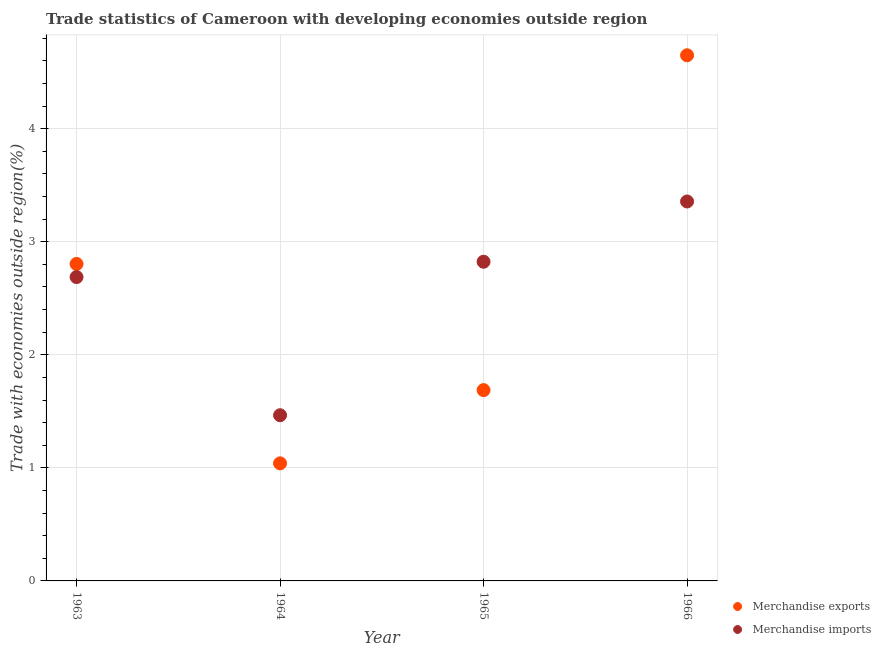What is the merchandise imports in 1963?
Make the answer very short. 2.69. Across all years, what is the maximum merchandise exports?
Offer a very short reply. 4.65. Across all years, what is the minimum merchandise exports?
Keep it short and to the point. 1.04. In which year was the merchandise imports maximum?
Provide a short and direct response. 1966. In which year was the merchandise imports minimum?
Ensure brevity in your answer.  1964. What is the total merchandise exports in the graph?
Give a very brief answer. 10.18. What is the difference between the merchandise exports in 1965 and that in 1966?
Ensure brevity in your answer.  -2.96. What is the difference between the merchandise imports in 1963 and the merchandise exports in 1966?
Provide a succinct answer. -1.96. What is the average merchandise exports per year?
Ensure brevity in your answer.  2.55. In the year 1966, what is the difference between the merchandise exports and merchandise imports?
Provide a succinct answer. 1.29. What is the ratio of the merchandise imports in 1964 to that in 1965?
Your answer should be very brief. 0.52. What is the difference between the highest and the second highest merchandise imports?
Keep it short and to the point. 0.53. What is the difference between the highest and the lowest merchandise imports?
Offer a terse response. 1.89. Is the sum of the merchandise exports in 1963 and 1965 greater than the maximum merchandise imports across all years?
Give a very brief answer. Yes. Is the merchandise exports strictly greater than the merchandise imports over the years?
Offer a terse response. No. How many dotlines are there?
Your answer should be compact. 2. How many years are there in the graph?
Offer a terse response. 4. Are the values on the major ticks of Y-axis written in scientific E-notation?
Keep it short and to the point. No. Does the graph contain any zero values?
Offer a very short reply. No. Does the graph contain grids?
Ensure brevity in your answer.  Yes. Where does the legend appear in the graph?
Offer a very short reply. Bottom right. What is the title of the graph?
Offer a very short reply. Trade statistics of Cameroon with developing economies outside region. Does "Investment" appear as one of the legend labels in the graph?
Keep it short and to the point. No. What is the label or title of the X-axis?
Your answer should be compact. Year. What is the label or title of the Y-axis?
Provide a short and direct response. Trade with economies outside region(%). What is the Trade with economies outside region(%) of Merchandise exports in 1963?
Offer a terse response. 2.8. What is the Trade with economies outside region(%) in Merchandise imports in 1963?
Provide a short and direct response. 2.69. What is the Trade with economies outside region(%) of Merchandise exports in 1964?
Keep it short and to the point. 1.04. What is the Trade with economies outside region(%) of Merchandise imports in 1964?
Offer a very short reply. 1.47. What is the Trade with economies outside region(%) of Merchandise exports in 1965?
Offer a very short reply. 1.69. What is the Trade with economies outside region(%) of Merchandise imports in 1965?
Ensure brevity in your answer.  2.82. What is the Trade with economies outside region(%) in Merchandise exports in 1966?
Offer a very short reply. 4.65. What is the Trade with economies outside region(%) in Merchandise imports in 1966?
Provide a succinct answer. 3.36. Across all years, what is the maximum Trade with economies outside region(%) in Merchandise exports?
Your answer should be very brief. 4.65. Across all years, what is the maximum Trade with economies outside region(%) in Merchandise imports?
Ensure brevity in your answer.  3.36. Across all years, what is the minimum Trade with economies outside region(%) of Merchandise exports?
Offer a terse response. 1.04. Across all years, what is the minimum Trade with economies outside region(%) of Merchandise imports?
Your answer should be very brief. 1.47. What is the total Trade with economies outside region(%) in Merchandise exports in the graph?
Provide a succinct answer. 10.18. What is the total Trade with economies outside region(%) of Merchandise imports in the graph?
Offer a very short reply. 10.33. What is the difference between the Trade with economies outside region(%) of Merchandise exports in 1963 and that in 1964?
Your answer should be compact. 1.76. What is the difference between the Trade with economies outside region(%) of Merchandise imports in 1963 and that in 1964?
Your answer should be very brief. 1.22. What is the difference between the Trade with economies outside region(%) in Merchandise exports in 1963 and that in 1965?
Provide a short and direct response. 1.12. What is the difference between the Trade with economies outside region(%) of Merchandise imports in 1963 and that in 1965?
Provide a short and direct response. -0.14. What is the difference between the Trade with economies outside region(%) of Merchandise exports in 1963 and that in 1966?
Your answer should be compact. -1.85. What is the difference between the Trade with economies outside region(%) in Merchandise imports in 1963 and that in 1966?
Provide a succinct answer. -0.67. What is the difference between the Trade with economies outside region(%) of Merchandise exports in 1964 and that in 1965?
Offer a terse response. -0.65. What is the difference between the Trade with economies outside region(%) of Merchandise imports in 1964 and that in 1965?
Your answer should be compact. -1.36. What is the difference between the Trade with economies outside region(%) of Merchandise exports in 1964 and that in 1966?
Your response must be concise. -3.61. What is the difference between the Trade with economies outside region(%) in Merchandise imports in 1964 and that in 1966?
Make the answer very short. -1.89. What is the difference between the Trade with economies outside region(%) in Merchandise exports in 1965 and that in 1966?
Provide a succinct answer. -2.96. What is the difference between the Trade with economies outside region(%) in Merchandise imports in 1965 and that in 1966?
Provide a short and direct response. -0.53. What is the difference between the Trade with economies outside region(%) of Merchandise exports in 1963 and the Trade with economies outside region(%) of Merchandise imports in 1964?
Offer a terse response. 1.34. What is the difference between the Trade with economies outside region(%) of Merchandise exports in 1963 and the Trade with economies outside region(%) of Merchandise imports in 1965?
Your answer should be compact. -0.02. What is the difference between the Trade with economies outside region(%) of Merchandise exports in 1963 and the Trade with economies outside region(%) of Merchandise imports in 1966?
Ensure brevity in your answer.  -0.55. What is the difference between the Trade with economies outside region(%) in Merchandise exports in 1964 and the Trade with economies outside region(%) in Merchandise imports in 1965?
Your response must be concise. -1.78. What is the difference between the Trade with economies outside region(%) in Merchandise exports in 1964 and the Trade with economies outside region(%) in Merchandise imports in 1966?
Your answer should be compact. -2.32. What is the difference between the Trade with economies outside region(%) in Merchandise exports in 1965 and the Trade with economies outside region(%) in Merchandise imports in 1966?
Offer a terse response. -1.67. What is the average Trade with economies outside region(%) of Merchandise exports per year?
Provide a short and direct response. 2.55. What is the average Trade with economies outside region(%) of Merchandise imports per year?
Provide a succinct answer. 2.58. In the year 1963, what is the difference between the Trade with economies outside region(%) of Merchandise exports and Trade with economies outside region(%) of Merchandise imports?
Offer a very short reply. 0.12. In the year 1964, what is the difference between the Trade with economies outside region(%) in Merchandise exports and Trade with economies outside region(%) in Merchandise imports?
Provide a short and direct response. -0.43. In the year 1965, what is the difference between the Trade with economies outside region(%) of Merchandise exports and Trade with economies outside region(%) of Merchandise imports?
Offer a terse response. -1.14. In the year 1966, what is the difference between the Trade with economies outside region(%) of Merchandise exports and Trade with economies outside region(%) of Merchandise imports?
Provide a succinct answer. 1.29. What is the ratio of the Trade with economies outside region(%) of Merchandise exports in 1963 to that in 1964?
Give a very brief answer. 2.7. What is the ratio of the Trade with economies outside region(%) of Merchandise imports in 1963 to that in 1964?
Your answer should be very brief. 1.83. What is the ratio of the Trade with economies outside region(%) of Merchandise exports in 1963 to that in 1965?
Offer a very short reply. 1.66. What is the ratio of the Trade with economies outside region(%) of Merchandise imports in 1963 to that in 1965?
Give a very brief answer. 0.95. What is the ratio of the Trade with economies outside region(%) in Merchandise exports in 1963 to that in 1966?
Offer a very short reply. 0.6. What is the ratio of the Trade with economies outside region(%) of Merchandise imports in 1963 to that in 1966?
Your response must be concise. 0.8. What is the ratio of the Trade with economies outside region(%) in Merchandise exports in 1964 to that in 1965?
Your answer should be compact. 0.62. What is the ratio of the Trade with economies outside region(%) in Merchandise imports in 1964 to that in 1965?
Your response must be concise. 0.52. What is the ratio of the Trade with economies outside region(%) of Merchandise exports in 1964 to that in 1966?
Give a very brief answer. 0.22. What is the ratio of the Trade with economies outside region(%) in Merchandise imports in 1964 to that in 1966?
Keep it short and to the point. 0.44. What is the ratio of the Trade with economies outside region(%) of Merchandise exports in 1965 to that in 1966?
Ensure brevity in your answer.  0.36. What is the ratio of the Trade with economies outside region(%) of Merchandise imports in 1965 to that in 1966?
Keep it short and to the point. 0.84. What is the difference between the highest and the second highest Trade with economies outside region(%) in Merchandise exports?
Give a very brief answer. 1.85. What is the difference between the highest and the second highest Trade with economies outside region(%) of Merchandise imports?
Give a very brief answer. 0.53. What is the difference between the highest and the lowest Trade with economies outside region(%) of Merchandise exports?
Your response must be concise. 3.61. What is the difference between the highest and the lowest Trade with economies outside region(%) of Merchandise imports?
Provide a succinct answer. 1.89. 